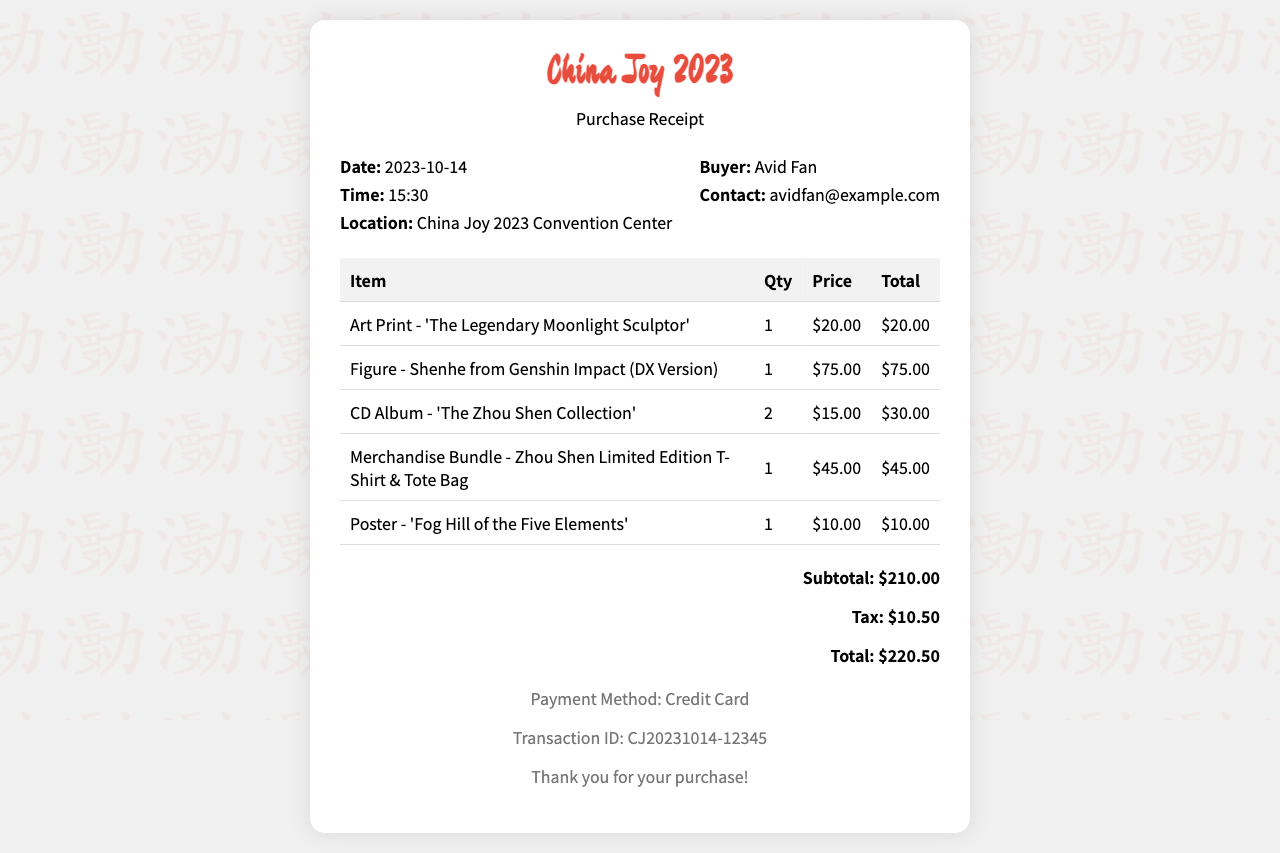What is the date of the purchase? The date of the purchase is stated in the receipt under the "Date" label.
Answer: 2023-10-14 What item has the highest price? The item with the highest price is seen in the table with the "Price" column, which identifies the most expensive item.
Answer: Figure - Shenhe from Genshin Impact (DX Version) How many CD albums were purchased? The quantity of CD albums is specified in the quantity column of the receipt's table.
Answer: 2 What is the subtotal amount? The subtotal is listed at the bottom of the receipt, immediately preceding the tax and total.
Answer: $210.00 What payment method was used? The payment method can be found in the footer section of the receipt.
Answer: Credit Card What was the total cost after tax? The total cost is the last figure shown in the total section of the receipt, summed including tax.
Answer: $220.50 Who is the buyer according to the receipt? The buyer is mentioned in the buyer's information section of the receipt.
Answer: Avid Fan What is the Transaction ID? The transaction ID is provided towards the end of the receipt in the footer, identified under a distinct label.
Answer: CJ20231014-12345 How much tax was paid? The tax amount is detailed in the total section of the receipt, clearly labeled as "Tax."
Answer: $10.50 